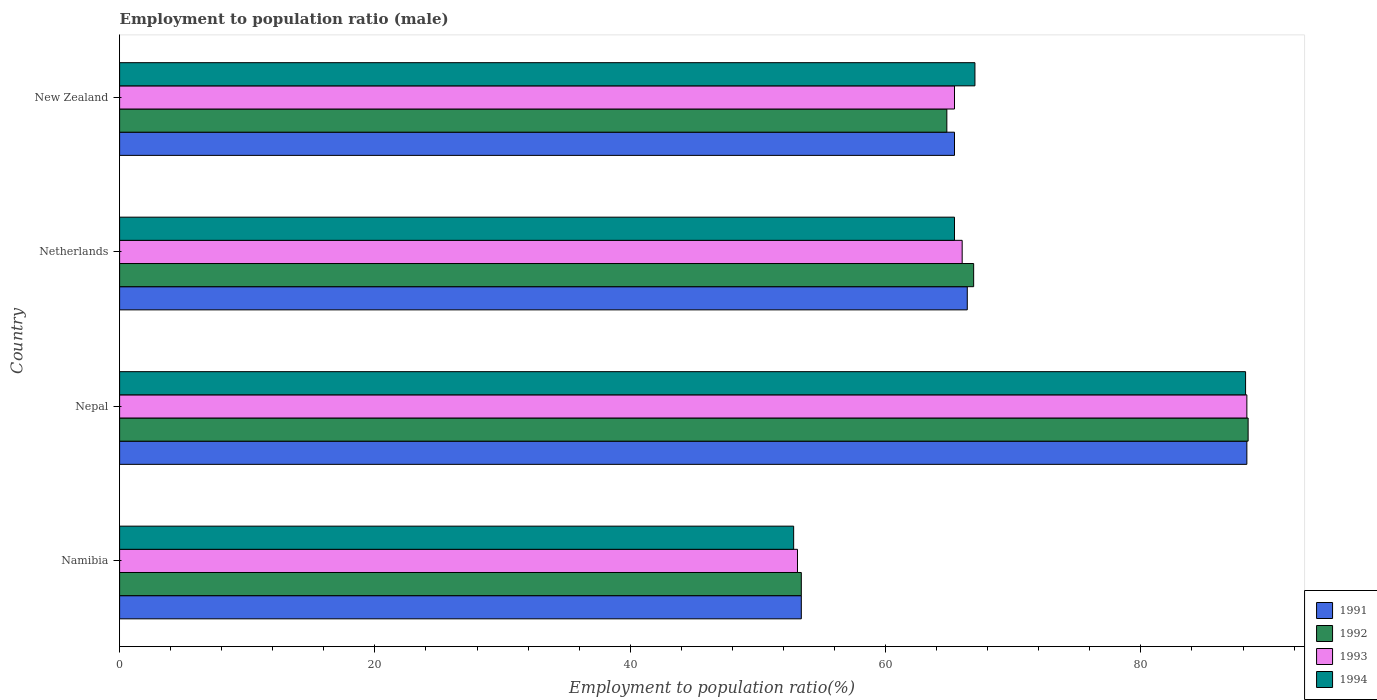How many different coloured bars are there?
Provide a succinct answer. 4. How many groups of bars are there?
Your answer should be compact. 4. Are the number of bars per tick equal to the number of legend labels?
Offer a terse response. Yes. Are the number of bars on each tick of the Y-axis equal?
Give a very brief answer. Yes. How many bars are there on the 1st tick from the bottom?
Your answer should be very brief. 4. What is the label of the 4th group of bars from the top?
Keep it short and to the point. Namibia. In how many cases, is the number of bars for a given country not equal to the number of legend labels?
Your answer should be compact. 0. What is the employment to population ratio in 1993 in Namibia?
Your answer should be compact. 53.1. Across all countries, what is the maximum employment to population ratio in 1992?
Provide a short and direct response. 88.4. Across all countries, what is the minimum employment to population ratio in 1994?
Offer a very short reply. 52.8. In which country was the employment to population ratio in 1992 maximum?
Offer a terse response. Nepal. In which country was the employment to population ratio in 1992 minimum?
Ensure brevity in your answer.  Namibia. What is the total employment to population ratio in 1992 in the graph?
Ensure brevity in your answer.  273.5. What is the difference between the employment to population ratio in 1991 in Nepal and that in New Zealand?
Give a very brief answer. 22.9. What is the difference between the employment to population ratio in 1994 in Namibia and the employment to population ratio in 1992 in New Zealand?
Make the answer very short. -12. What is the average employment to population ratio in 1993 per country?
Keep it short and to the point. 68.2. What is the difference between the employment to population ratio in 1991 and employment to population ratio in 1993 in Nepal?
Make the answer very short. 0. What is the ratio of the employment to population ratio in 1992 in Namibia to that in Nepal?
Your answer should be very brief. 0.6. What is the difference between the highest and the second highest employment to population ratio in 1994?
Your response must be concise. 21.2. What is the difference between the highest and the lowest employment to population ratio in 1994?
Offer a very short reply. 35.4. In how many countries, is the employment to population ratio in 1994 greater than the average employment to population ratio in 1994 taken over all countries?
Give a very brief answer. 1. What does the 4th bar from the top in Netherlands represents?
Make the answer very short. 1991. Does the graph contain any zero values?
Make the answer very short. No. How many legend labels are there?
Keep it short and to the point. 4. What is the title of the graph?
Your answer should be compact. Employment to population ratio (male). What is the label or title of the X-axis?
Make the answer very short. Employment to population ratio(%). What is the Employment to population ratio(%) of 1991 in Namibia?
Provide a succinct answer. 53.4. What is the Employment to population ratio(%) in 1992 in Namibia?
Keep it short and to the point. 53.4. What is the Employment to population ratio(%) in 1993 in Namibia?
Your answer should be compact. 53.1. What is the Employment to population ratio(%) in 1994 in Namibia?
Ensure brevity in your answer.  52.8. What is the Employment to population ratio(%) in 1991 in Nepal?
Make the answer very short. 88.3. What is the Employment to population ratio(%) of 1992 in Nepal?
Your answer should be very brief. 88.4. What is the Employment to population ratio(%) in 1993 in Nepal?
Provide a succinct answer. 88.3. What is the Employment to population ratio(%) of 1994 in Nepal?
Keep it short and to the point. 88.2. What is the Employment to population ratio(%) in 1991 in Netherlands?
Provide a short and direct response. 66.4. What is the Employment to population ratio(%) of 1992 in Netherlands?
Your answer should be compact. 66.9. What is the Employment to population ratio(%) in 1994 in Netherlands?
Keep it short and to the point. 65.4. What is the Employment to population ratio(%) of 1991 in New Zealand?
Provide a succinct answer. 65.4. What is the Employment to population ratio(%) of 1992 in New Zealand?
Offer a terse response. 64.8. What is the Employment to population ratio(%) of 1993 in New Zealand?
Make the answer very short. 65.4. What is the Employment to population ratio(%) in 1994 in New Zealand?
Offer a very short reply. 67. Across all countries, what is the maximum Employment to population ratio(%) in 1991?
Provide a short and direct response. 88.3. Across all countries, what is the maximum Employment to population ratio(%) of 1992?
Your response must be concise. 88.4. Across all countries, what is the maximum Employment to population ratio(%) in 1993?
Offer a terse response. 88.3. Across all countries, what is the maximum Employment to population ratio(%) in 1994?
Your response must be concise. 88.2. Across all countries, what is the minimum Employment to population ratio(%) of 1991?
Ensure brevity in your answer.  53.4. Across all countries, what is the minimum Employment to population ratio(%) of 1992?
Your response must be concise. 53.4. Across all countries, what is the minimum Employment to population ratio(%) of 1993?
Your answer should be compact. 53.1. Across all countries, what is the minimum Employment to population ratio(%) of 1994?
Your answer should be very brief. 52.8. What is the total Employment to population ratio(%) in 1991 in the graph?
Offer a terse response. 273.5. What is the total Employment to population ratio(%) in 1992 in the graph?
Ensure brevity in your answer.  273.5. What is the total Employment to population ratio(%) in 1993 in the graph?
Give a very brief answer. 272.8. What is the total Employment to population ratio(%) of 1994 in the graph?
Provide a succinct answer. 273.4. What is the difference between the Employment to population ratio(%) in 1991 in Namibia and that in Nepal?
Offer a terse response. -34.9. What is the difference between the Employment to population ratio(%) of 1992 in Namibia and that in Nepal?
Offer a very short reply. -35. What is the difference between the Employment to population ratio(%) of 1993 in Namibia and that in Nepal?
Give a very brief answer. -35.2. What is the difference between the Employment to population ratio(%) in 1994 in Namibia and that in Nepal?
Give a very brief answer. -35.4. What is the difference between the Employment to population ratio(%) of 1991 in Namibia and that in Netherlands?
Make the answer very short. -13. What is the difference between the Employment to population ratio(%) of 1994 in Namibia and that in Netherlands?
Provide a succinct answer. -12.6. What is the difference between the Employment to population ratio(%) of 1991 in Nepal and that in Netherlands?
Ensure brevity in your answer.  21.9. What is the difference between the Employment to population ratio(%) in 1993 in Nepal and that in Netherlands?
Provide a short and direct response. 22.3. What is the difference between the Employment to population ratio(%) in 1994 in Nepal and that in Netherlands?
Ensure brevity in your answer.  22.8. What is the difference between the Employment to population ratio(%) in 1991 in Nepal and that in New Zealand?
Your answer should be compact. 22.9. What is the difference between the Employment to population ratio(%) of 1992 in Nepal and that in New Zealand?
Keep it short and to the point. 23.6. What is the difference between the Employment to population ratio(%) of 1993 in Nepal and that in New Zealand?
Provide a succinct answer. 22.9. What is the difference between the Employment to population ratio(%) of 1994 in Nepal and that in New Zealand?
Offer a terse response. 21.2. What is the difference between the Employment to population ratio(%) in 1992 in Netherlands and that in New Zealand?
Your response must be concise. 2.1. What is the difference between the Employment to population ratio(%) of 1993 in Netherlands and that in New Zealand?
Give a very brief answer. 0.6. What is the difference between the Employment to population ratio(%) in 1994 in Netherlands and that in New Zealand?
Offer a terse response. -1.6. What is the difference between the Employment to population ratio(%) in 1991 in Namibia and the Employment to population ratio(%) in 1992 in Nepal?
Offer a very short reply. -35. What is the difference between the Employment to population ratio(%) in 1991 in Namibia and the Employment to population ratio(%) in 1993 in Nepal?
Your answer should be compact. -34.9. What is the difference between the Employment to population ratio(%) of 1991 in Namibia and the Employment to population ratio(%) of 1994 in Nepal?
Your answer should be compact. -34.8. What is the difference between the Employment to population ratio(%) of 1992 in Namibia and the Employment to population ratio(%) of 1993 in Nepal?
Your answer should be compact. -34.9. What is the difference between the Employment to population ratio(%) of 1992 in Namibia and the Employment to population ratio(%) of 1994 in Nepal?
Your answer should be compact. -34.8. What is the difference between the Employment to population ratio(%) of 1993 in Namibia and the Employment to population ratio(%) of 1994 in Nepal?
Make the answer very short. -35.1. What is the difference between the Employment to population ratio(%) in 1991 in Namibia and the Employment to population ratio(%) in 1993 in Netherlands?
Give a very brief answer. -12.6. What is the difference between the Employment to population ratio(%) in 1991 in Namibia and the Employment to population ratio(%) in 1994 in Netherlands?
Ensure brevity in your answer.  -12. What is the difference between the Employment to population ratio(%) of 1992 in Namibia and the Employment to population ratio(%) of 1993 in Netherlands?
Your answer should be very brief. -12.6. What is the difference between the Employment to population ratio(%) of 1993 in Namibia and the Employment to population ratio(%) of 1994 in Netherlands?
Provide a short and direct response. -12.3. What is the difference between the Employment to population ratio(%) in 1992 in Namibia and the Employment to population ratio(%) in 1993 in New Zealand?
Ensure brevity in your answer.  -12. What is the difference between the Employment to population ratio(%) of 1992 in Namibia and the Employment to population ratio(%) of 1994 in New Zealand?
Your answer should be compact. -13.6. What is the difference between the Employment to population ratio(%) of 1991 in Nepal and the Employment to population ratio(%) of 1992 in Netherlands?
Keep it short and to the point. 21.4. What is the difference between the Employment to population ratio(%) of 1991 in Nepal and the Employment to population ratio(%) of 1993 in Netherlands?
Your answer should be compact. 22.3. What is the difference between the Employment to population ratio(%) in 1991 in Nepal and the Employment to population ratio(%) in 1994 in Netherlands?
Ensure brevity in your answer.  22.9. What is the difference between the Employment to population ratio(%) of 1992 in Nepal and the Employment to population ratio(%) of 1993 in Netherlands?
Ensure brevity in your answer.  22.4. What is the difference between the Employment to population ratio(%) of 1993 in Nepal and the Employment to population ratio(%) of 1994 in Netherlands?
Your answer should be compact. 22.9. What is the difference between the Employment to population ratio(%) in 1991 in Nepal and the Employment to population ratio(%) in 1992 in New Zealand?
Ensure brevity in your answer.  23.5. What is the difference between the Employment to population ratio(%) of 1991 in Nepal and the Employment to population ratio(%) of 1993 in New Zealand?
Your answer should be compact. 22.9. What is the difference between the Employment to population ratio(%) of 1991 in Nepal and the Employment to population ratio(%) of 1994 in New Zealand?
Offer a terse response. 21.3. What is the difference between the Employment to population ratio(%) in 1992 in Nepal and the Employment to population ratio(%) in 1993 in New Zealand?
Provide a succinct answer. 23. What is the difference between the Employment to population ratio(%) of 1992 in Nepal and the Employment to population ratio(%) of 1994 in New Zealand?
Make the answer very short. 21.4. What is the difference between the Employment to population ratio(%) of 1993 in Nepal and the Employment to population ratio(%) of 1994 in New Zealand?
Keep it short and to the point. 21.3. What is the difference between the Employment to population ratio(%) of 1991 in Netherlands and the Employment to population ratio(%) of 1994 in New Zealand?
Keep it short and to the point. -0.6. What is the difference between the Employment to population ratio(%) in 1992 in Netherlands and the Employment to population ratio(%) in 1993 in New Zealand?
Make the answer very short. 1.5. What is the difference between the Employment to population ratio(%) of 1992 in Netherlands and the Employment to population ratio(%) of 1994 in New Zealand?
Your response must be concise. -0.1. What is the average Employment to population ratio(%) of 1991 per country?
Your answer should be very brief. 68.38. What is the average Employment to population ratio(%) of 1992 per country?
Offer a terse response. 68.38. What is the average Employment to population ratio(%) in 1993 per country?
Provide a succinct answer. 68.2. What is the average Employment to population ratio(%) in 1994 per country?
Your answer should be compact. 68.35. What is the difference between the Employment to population ratio(%) of 1992 and Employment to population ratio(%) of 1993 in Namibia?
Keep it short and to the point. 0.3. What is the difference between the Employment to population ratio(%) in 1991 and Employment to population ratio(%) in 1992 in Nepal?
Provide a short and direct response. -0.1. What is the difference between the Employment to population ratio(%) of 1991 and Employment to population ratio(%) of 1994 in Nepal?
Offer a terse response. 0.1. What is the difference between the Employment to population ratio(%) of 1992 and Employment to population ratio(%) of 1994 in Nepal?
Offer a very short reply. 0.2. What is the difference between the Employment to population ratio(%) of 1991 and Employment to population ratio(%) of 1993 in Netherlands?
Offer a very short reply. 0.4. What is the difference between the Employment to population ratio(%) of 1991 and Employment to population ratio(%) of 1994 in Netherlands?
Provide a succinct answer. 1. What is the difference between the Employment to population ratio(%) of 1993 and Employment to population ratio(%) of 1994 in Netherlands?
Your answer should be very brief. 0.6. What is the difference between the Employment to population ratio(%) of 1991 and Employment to population ratio(%) of 1992 in New Zealand?
Your response must be concise. 0.6. What is the difference between the Employment to population ratio(%) of 1991 and Employment to population ratio(%) of 1993 in New Zealand?
Offer a terse response. 0. What is the difference between the Employment to population ratio(%) of 1993 and Employment to population ratio(%) of 1994 in New Zealand?
Provide a short and direct response. -1.6. What is the ratio of the Employment to population ratio(%) of 1991 in Namibia to that in Nepal?
Give a very brief answer. 0.6. What is the ratio of the Employment to population ratio(%) in 1992 in Namibia to that in Nepal?
Your response must be concise. 0.6. What is the ratio of the Employment to population ratio(%) in 1993 in Namibia to that in Nepal?
Your answer should be very brief. 0.6. What is the ratio of the Employment to population ratio(%) of 1994 in Namibia to that in Nepal?
Provide a succinct answer. 0.6. What is the ratio of the Employment to population ratio(%) in 1991 in Namibia to that in Netherlands?
Keep it short and to the point. 0.8. What is the ratio of the Employment to population ratio(%) in 1992 in Namibia to that in Netherlands?
Offer a terse response. 0.8. What is the ratio of the Employment to population ratio(%) in 1993 in Namibia to that in Netherlands?
Offer a very short reply. 0.8. What is the ratio of the Employment to population ratio(%) of 1994 in Namibia to that in Netherlands?
Offer a very short reply. 0.81. What is the ratio of the Employment to population ratio(%) of 1991 in Namibia to that in New Zealand?
Provide a short and direct response. 0.82. What is the ratio of the Employment to population ratio(%) in 1992 in Namibia to that in New Zealand?
Give a very brief answer. 0.82. What is the ratio of the Employment to population ratio(%) in 1993 in Namibia to that in New Zealand?
Provide a succinct answer. 0.81. What is the ratio of the Employment to population ratio(%) of 1994 in Namibia to that in New Zealand?
Your answer should be compact. 0.79. What is the ratio of the Employment to population ratio(%) of 1991 in Nepal to that in Netherlands?
Ensure brevity in your answer.  1.33. What is the ratio of the Employment to population ratio(%) in 1992 in Nepal to that in Netherlands?
Ensure brevity in your answer.  1.32. What is the ratio of the Employment to population ratio(%) of 1993 in Nepal to that in Netherlands?
Provide a short and direct response. 1.34. What is the ratio of the Employment to population ratio(%) of 1994 in Nepal to that in Netherlands?
Your answer should be very brief. 1.35. What is the ratio of the Employment to population ratio(%) in 1991 in Nepal to that in New Zealand?
Make the answer very short. 1.35. What is the ratio of the Employment to population ratio(%) in 1992 in Nepal to that in New Zealand?
Keep it short and to the point. 1.36. What is the ratio of the Employment to population ratio(%) in 1993 in Nepal to that in New Zealand?
Make the answer very short. 1.35. What is the ratio of the Employment to population ratio(%) in 1994 in Nepal to that in New Zealand?
Make the answer very short. 1.32. What is the ratio of the Employment to population ratio(%) in 1991 in Netherlands to that in New Zealand?
Provide a short and direct response. 1.02. What is the ratio of the Employment to population ratio(%) in 1992 in Netherlands to that in New Zealand?
Your answer should be very brief. 1.03. What is the ratio of the Employment to population ratio(%) of 1993 in Netherlands to that in New Zealand?
Your response must be concise. 1.01. What is the ratio of the Employment to population ratio(%) of 1994 in Netherlands to that in New Zealand?
Your answer should be very brief. 0.98. What is the difference between the highest and the second highest Employment to population ratio(%) of 1991?
Your response must be concise. 21.9. What is the difference between the highest and the second highest Employment to population ratio(%) in 1993?
Offer a very short reply. 22.3. What is the difference between the highest and the second highest Employment to population ratio(%) in 1994?
Provide a succinct answer. 21.2. What is the difference between the highest and the lowest Employment to population ratio(%) in 1991?
Your response must be concise. 34.9. What is the difference between the highest and the lowest Employment to population ratio(%) in 1992?
Make the answer very short. 35. What is the difference between the highest and the lowest Employment to population ratio(%) of 1993?
Ensure brevity in your answer.  35.2. What is the difference between the highest and the lowest Employment to population ratio(%) in 1994?
Keep it short and to the point. 35.4. 